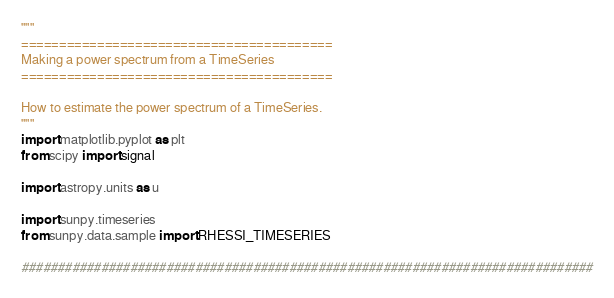<code> <loc_0><loc_0><loc_500><loc_500><_Python_>"""
=========================================
Making a power spectrum from a TimeSeries
=========================================

How to estimate the power spectrum of a TimeSeries.
"""
import matplotlib.pyplot as plt
from scipy import signal

import astropy.units as u

import sunpy.timeseries
from sunpy.data.sample import RHESSI_TIMESERIES

###############################################################################</code> 